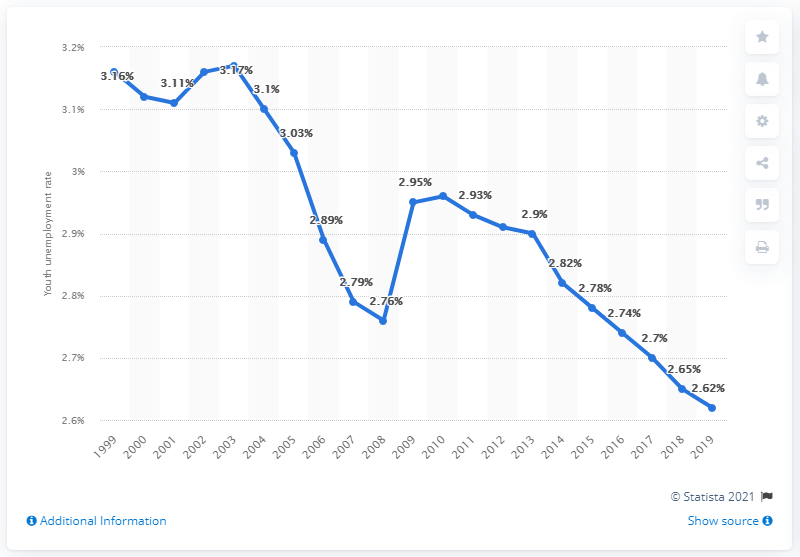Point out several critical features in this image. According to data from 2019, the youth unemployment rate in Burundi was 2.62%. 